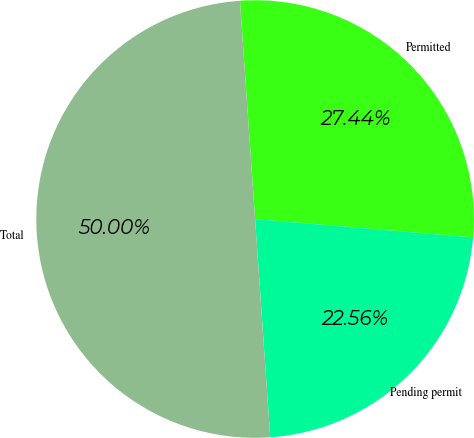Convert chart. <chart><loc_0><loc_0><loc_500><loc_500><pie_chart><fcel>Permitted<fcel>Pending permit<fcel>Total<nl><fcel>27.44%<fcel>22.56%<fcel>50.0%<nl></chart> 